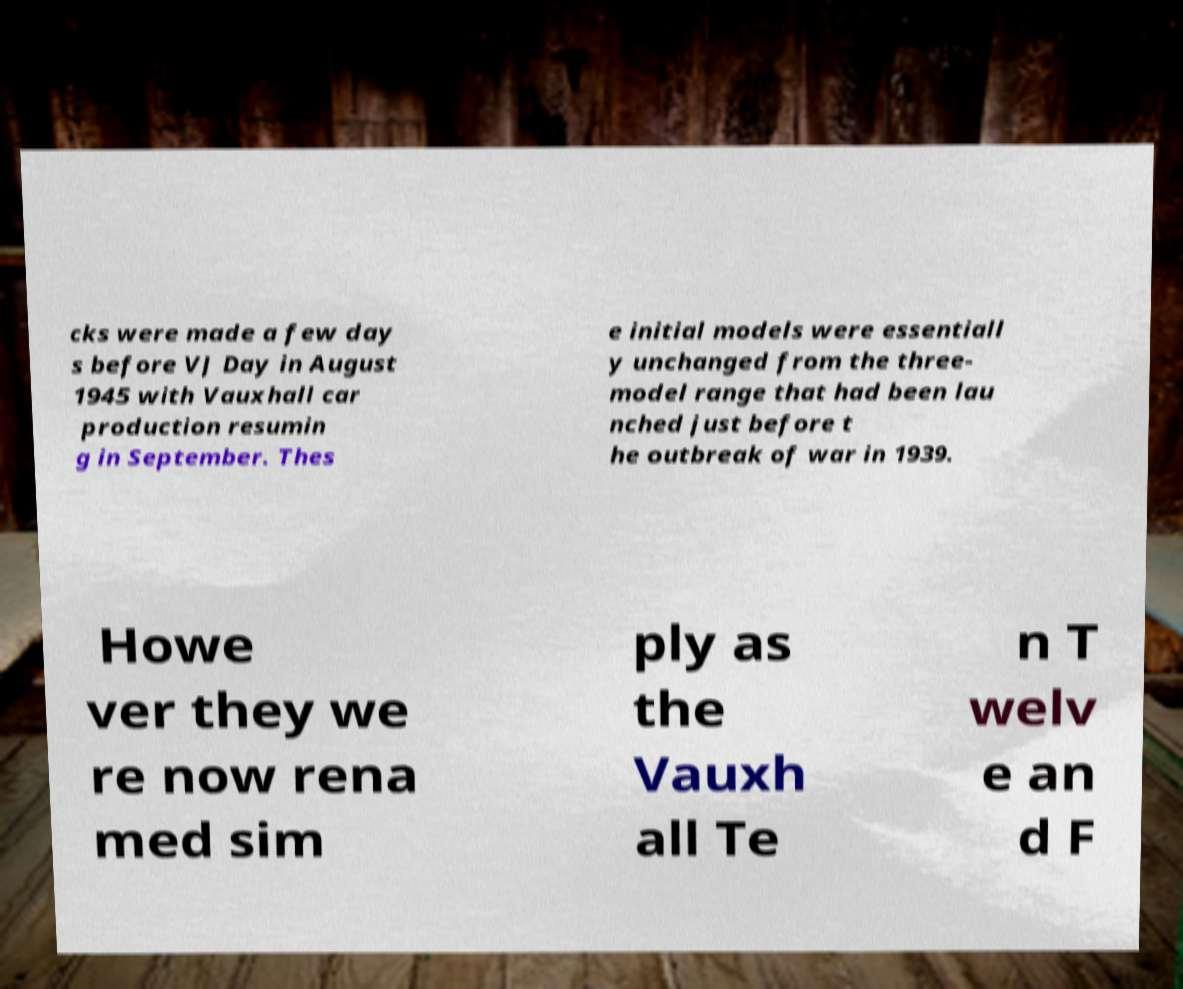For documentation purposes, I need the text within this image transcribed. Could you provide that? cks were made a few day s before VJ Day in August 1945 with Vauxhall car production resumin g in September. Thes e initial models were essentiall y unchanged from the three- model range that had been lau nched just before t he outbreak of war in 1939. Howe ver they we re now rena med sim ply as the Vauxh all Te n T welv e an d F 